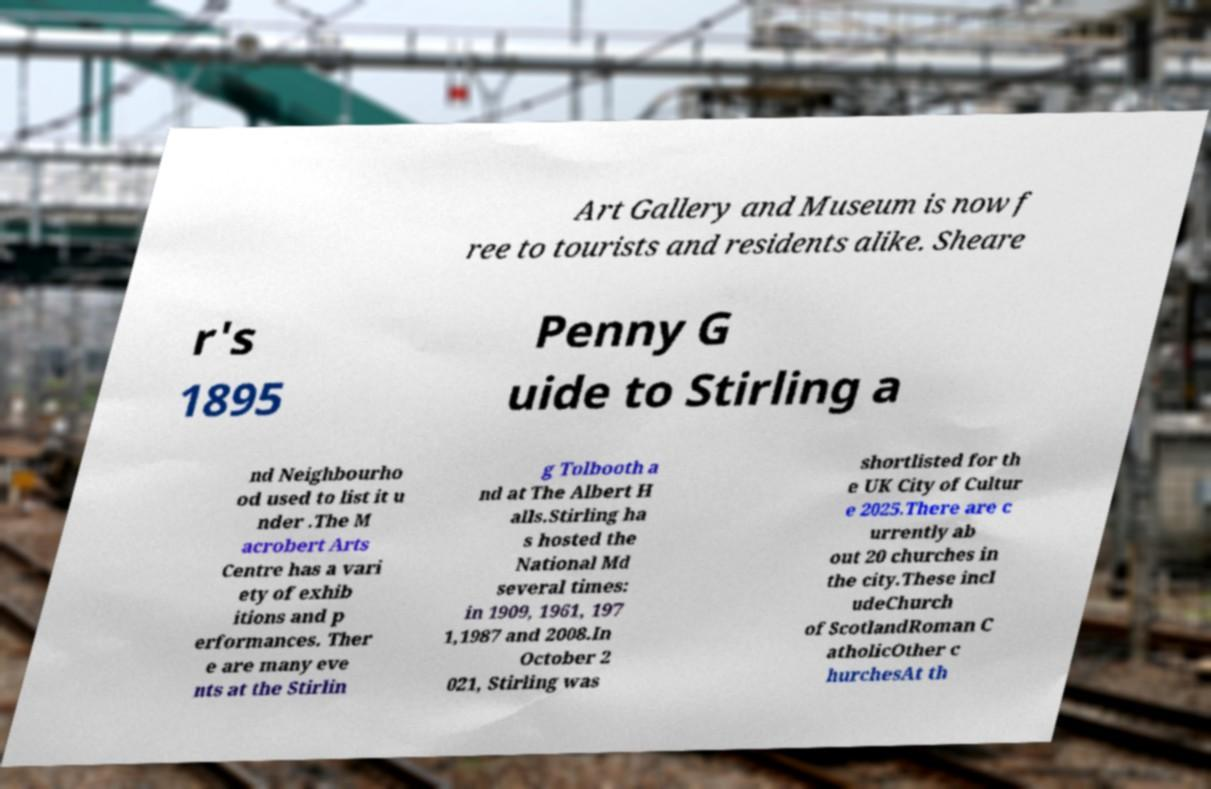Could you extract and type out the text from this image? Art Gallery and Museum is now f ree to tourists and residents alike. Sheare r's 1895 Penny G uide to Stirling a nd Neighbourho od used to list it u nder .The M acrobert Arts Centre has a vari ety of exhib itions and p erformances. Ther e are many eve nts at the Stirlin g Tolbooth a nd at The Albert H alls.Stirling ha s hosted the National Md several times: in 1909, 1961, 197 1,1987 and 2008.In October 2 021, Stirling was shortlisted for th e UK City of Cultur e 2025.There are c urrently ab out 20 churches in the city.These incl udeChurch of ScotlandRoman C atholicOther c hurchesAt th 